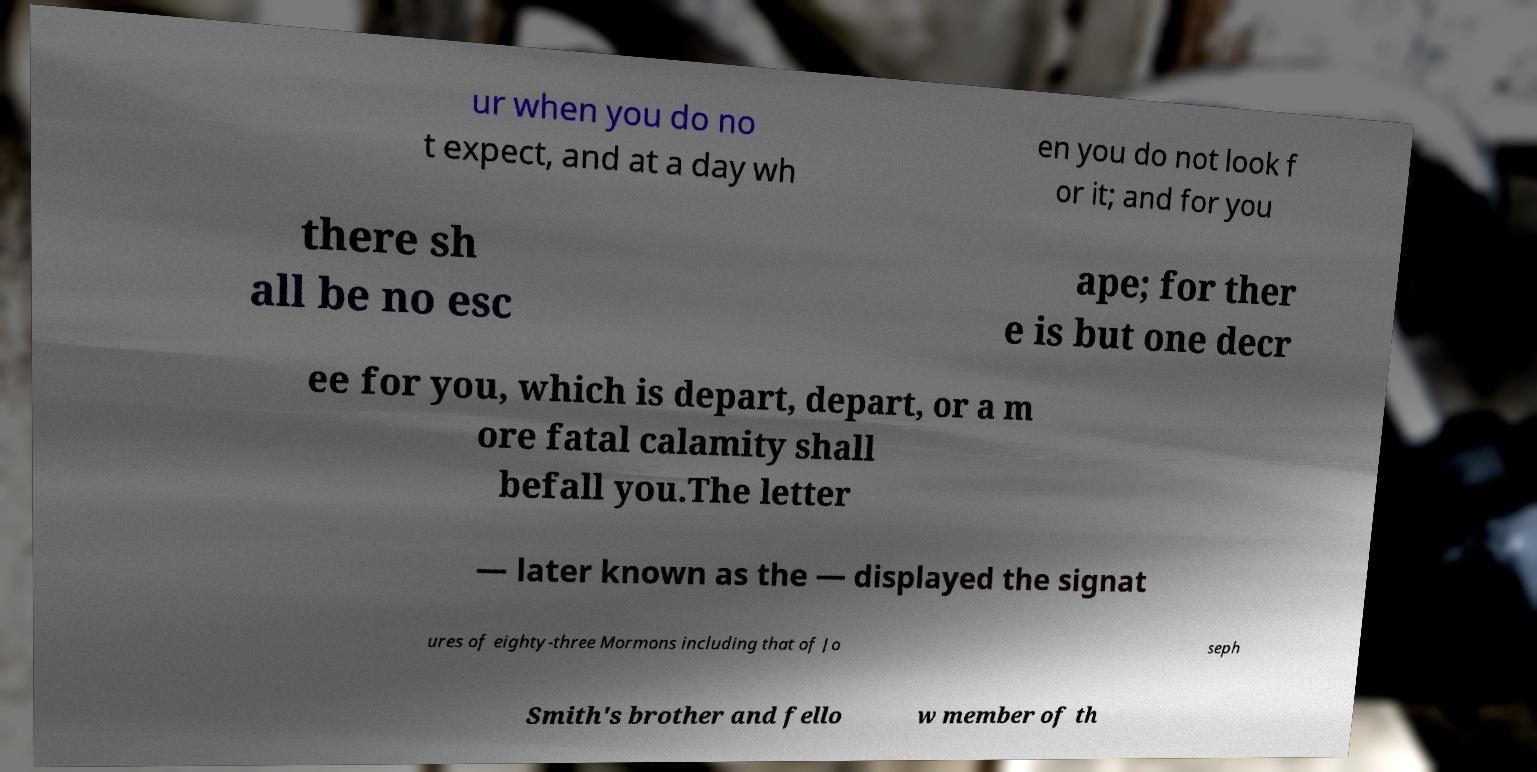I need the written content from this picture converted into text. Can you do that? ur when you do no t expect, and at a day wh en you do not look f or it; and for you there sh all be no esc ape; for ther e is but one decr ee for you, which is depart, depart, or a m ore fatal calamity shall befall you.The letter — later known as the — displayed the signat ures of eighty-three Mormons including that of Jo seph Smith's brother and fello w member of th 